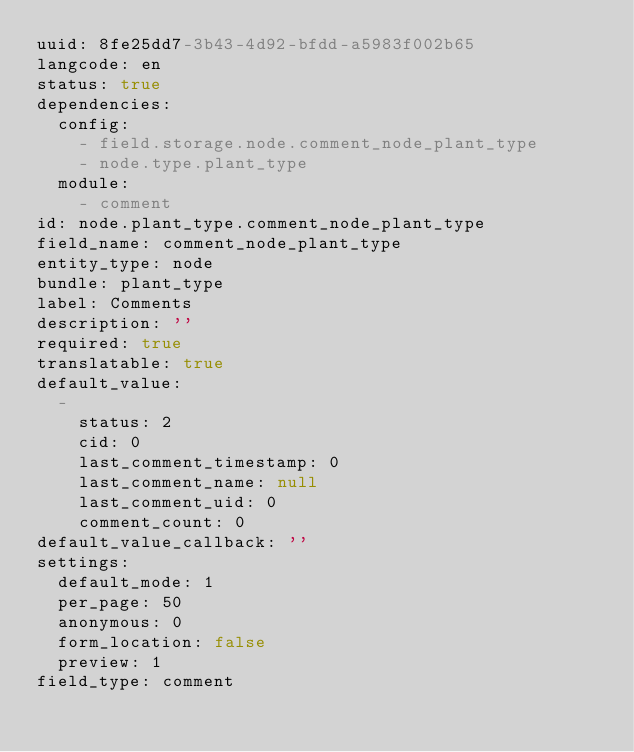Convert code to text. <code><loc_0><loc_0><loc_500><loc_500><_YAML_>uuid: 8fe25dd7-3b43-4d92-bfdd-a5983f002b65
langcode: en
status: true
dependencies:
  config:
    - field.storage.node.comment_node_plant_type
    - node.type.plant_type
  module:
    - comment
id: node.plant_type.comment_node_plant_type
field_name: comment_node_plant_type
entity_type: node
bundle: plant_type
label: Comments
description: ''
required: true
translatable: true
default_value:
  -
    status: 2
    cid: 0
    last_comment_timestamp: 0
    last_comment_name: null
    last_comment_uid: 0
    comment_count: 0
default_value_callback: ''
settings:
  default_mode: 1
  per_page: 50
  anonymous: 0
  form_location: false
  preview: 1
field_type: comment
</code> 